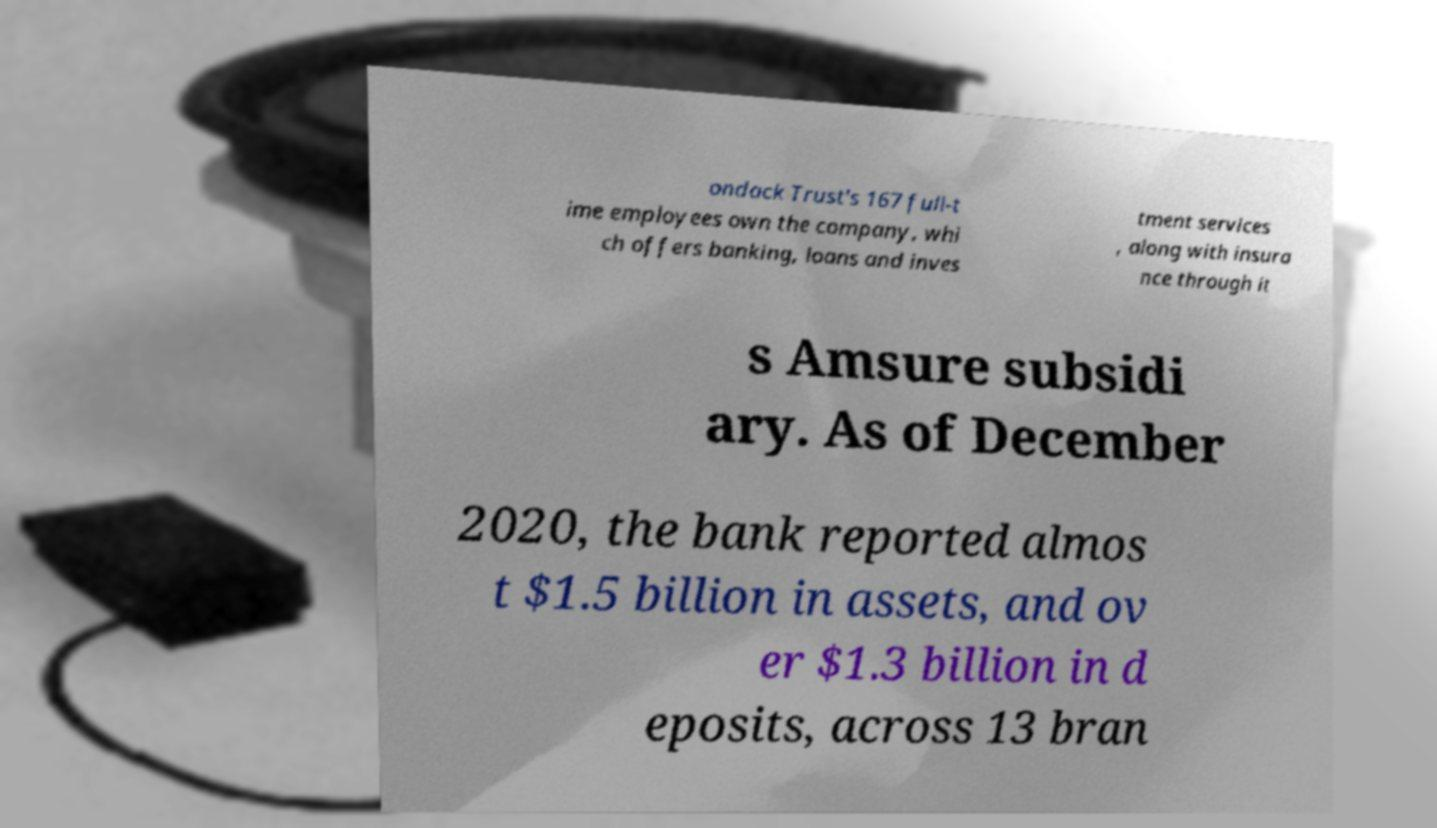For documentation purposes, I need the text within this image transcribed. Could you provide that? ondack Trust's 167 full-t ime employees own the company, whi ch offers banking, loans and inves tment services , along with insura nce through it s Amsure subsidi ary. As of December 2020, the bank reported almos t $1.5 billion in assets, and ov er $1.3 billion in d eposits, across 13 bran 